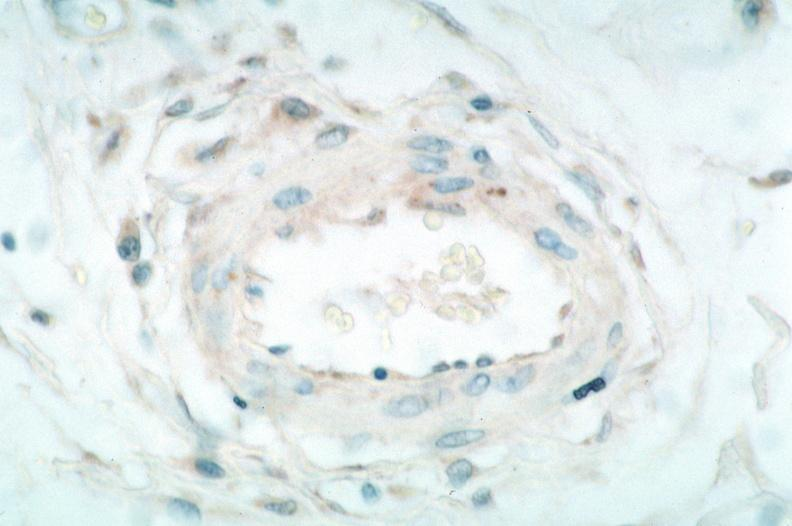s rocky mountain spotted fever, immunoperoxidase staining vessels for rickettsia rickettsii?
Answer the question using a single word or phrase. Yes 